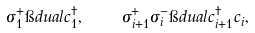<formula> <loc_0><loc_0><loc_500><loc_500>\sigma ^ { + } _ { 1 } \i d u a l c ^ { \dagger } _ { 1 } , \quad \sigma _ { i + 1 } ^ { + } \sigma _ { i } ^ { - } \i d u a l c _ { i + 1 } ^ { \dagger } c ^ { \, } _ { i } ,</formula> 